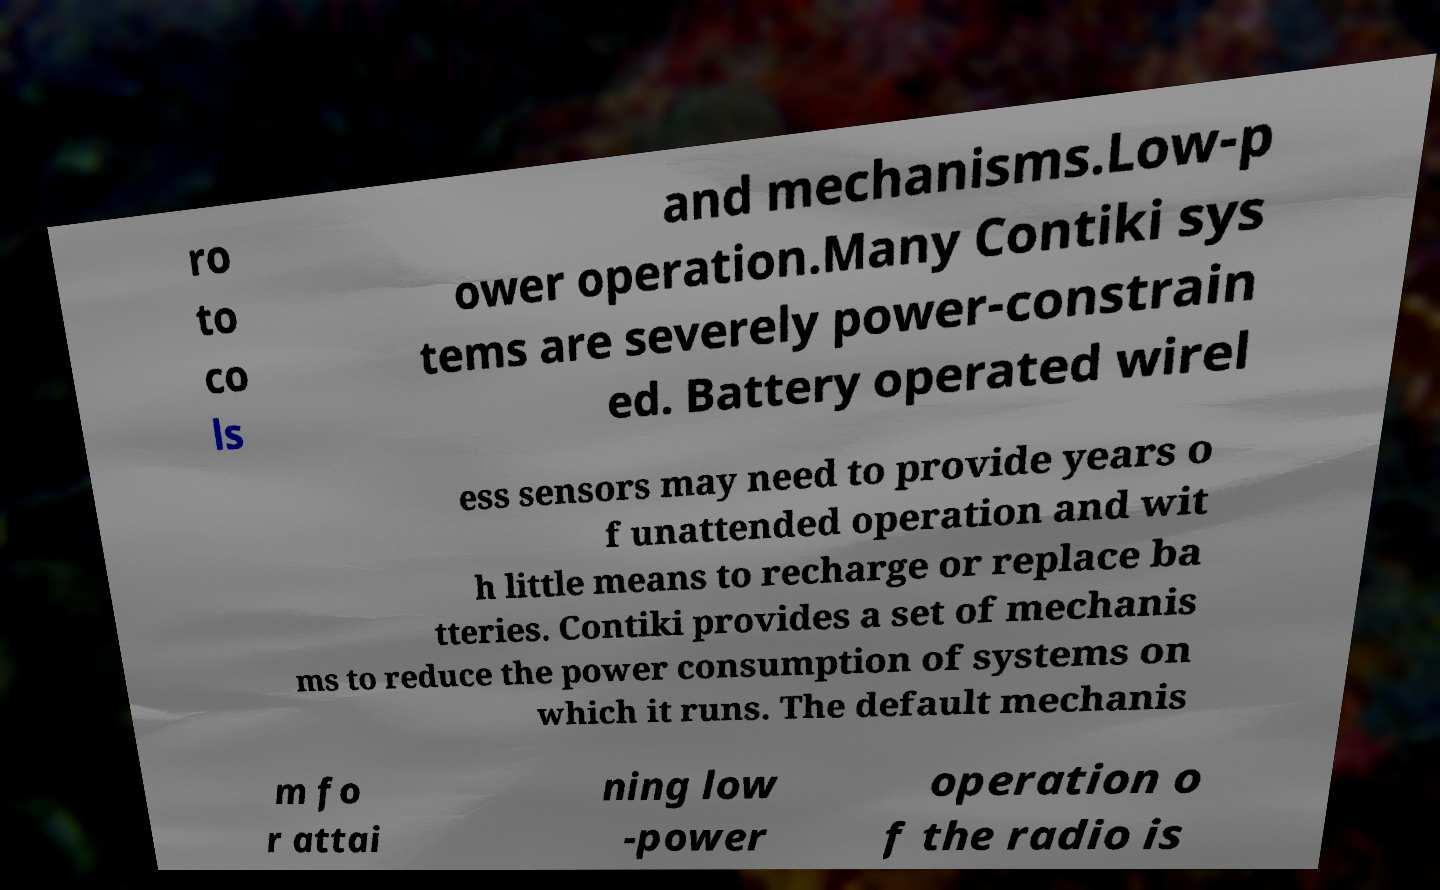Could you assist in decoding the text presented in this image and type it out clearly? ro to co ls and mechanisms.Low-p ower operation.Many Contiki sys tems are severely power-constrain ed. Battery operated wirel ess sensors may need to provide years o f unattended operation and wit h little means to recharge or replace ba tteries. Contiki provides a set of mechanis ms to reduce the power consumption of systems on which it runs. The default mechanis m fo r attai ning low -power operation o f the radio is 